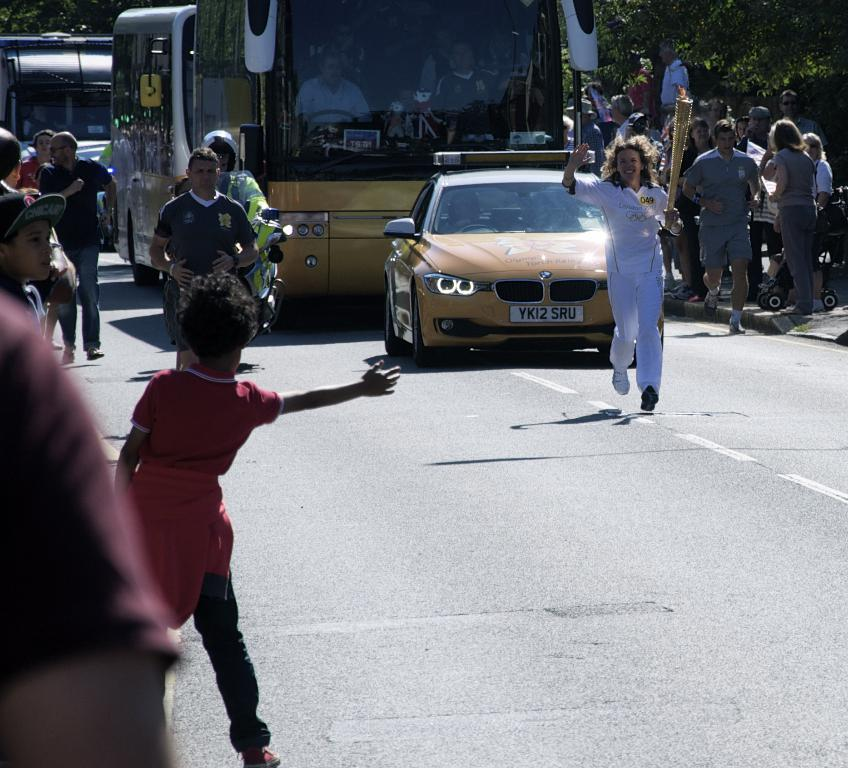What are the people in the image doing? Some people are running, some are walking, and some are standing. Can you describe the vehicles in the background? There is a bus and a car in the background. What is the setting of the image? The image features a road with trees in the background. What type of flesh can be seen on the people in the image? The people in the image are fully clothed, so there is no visible flesh. What sense is being stimulated by the presence of the trees in the background? The image is visual, so the sense being stimulated is sight, not touch or smell. 